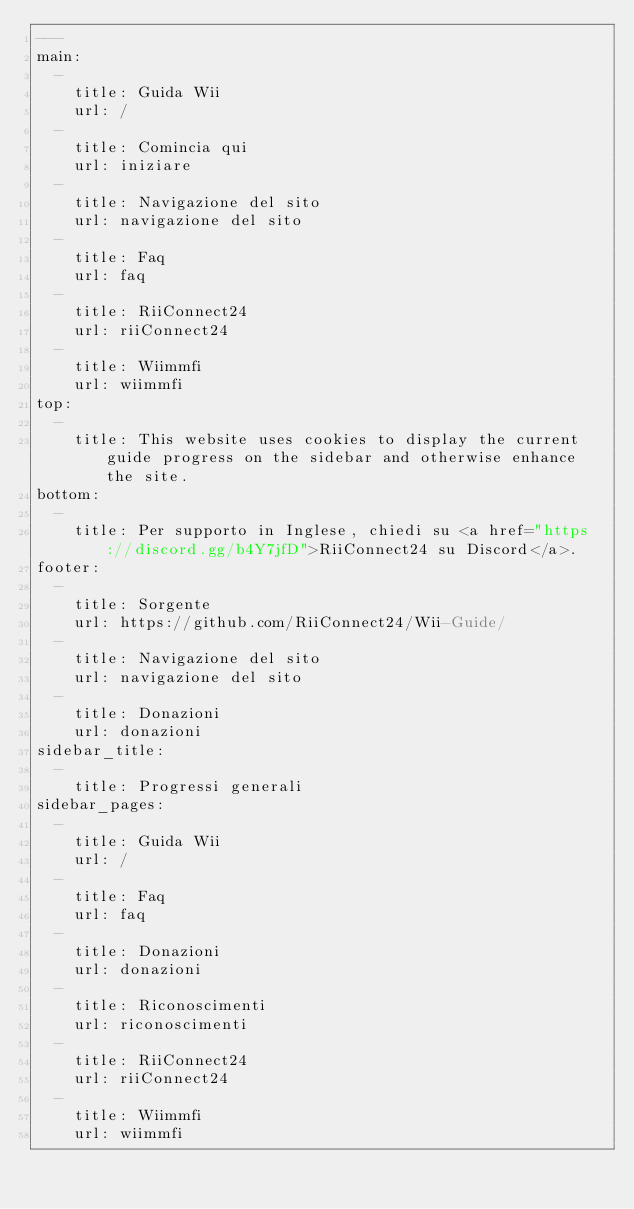Convert code to text. <code><loc_0><loc_0><loc_500><loc_500><_YAML_>---
main:
  - 
    title: Guida Wii
    url: /
  - 
    title: Comincia qui
    url: iniziare
  - 
    title: Navigazione del sito
    url: navigazione del sito
  - 
    title: Faq
    url: faq
  - 
    title: RiiConnect24
    url: riiConnect24
  - 
    title: Wiimmfi
    url: wiimmfi
top:
  -
    title: This website uses cookies to display the current guide progress on the sidebar and otherwise enhance the site.
bottom:
  - 
    title: Per supporto in Inglese, chiedi su <a href="https://discord.gg/b4Y7jfD">RiiConnect24 su Discord</a>.
footer:
  - 
    title: Sorgente
    url: https://github.com/RiiConnect24/Wii-Guide/
  - 
    title: Navigazione del sito
    url: navigazione del sito
  - 
    title: Donazioni
    url: donazioni
sidebar_title:
  - 
    title: Progressi generali
sidebar_pages:
  - 
    title: Guida Wii
    url: /
  - 
    title: Faq
    url: faq
  - 
    title: Donazioni
    url: donazioni
  - 
    title: Riconoscimenti
    url: riconoscimenti
  - 
    title: RiiConnect24
    url: riiConnect24
  - 
    title: Wiimmfi
    url: wiimmfi
</code> 